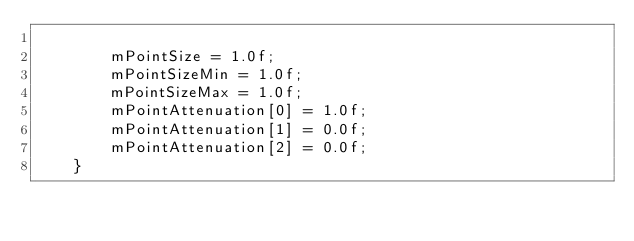Convert code to text. <code><loc_0><loc_0><loc_500><loc_500><_C++_>
        mPointSize = 1.0f;
        mPointSizeMin = 1.0f;
        mPointSizeMax = 1.0f;
        mPointAttenuation[0] = 1.0f;
        mPointAttenuation[1] = 0.0f;
        mPointAttenuation[2] = 0.0f;
    }
</code> 